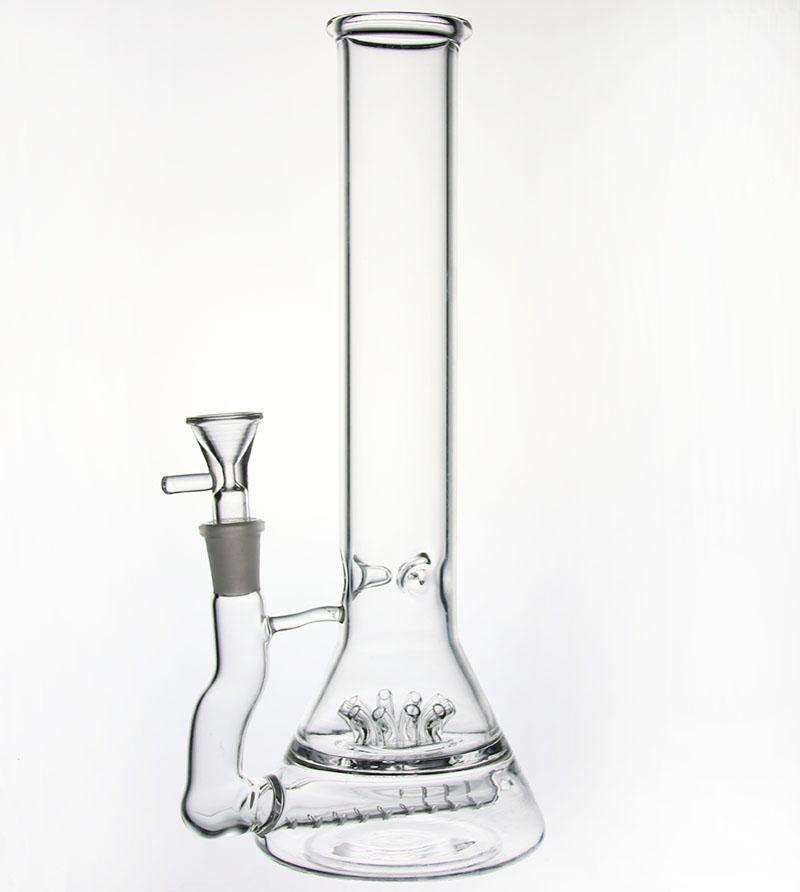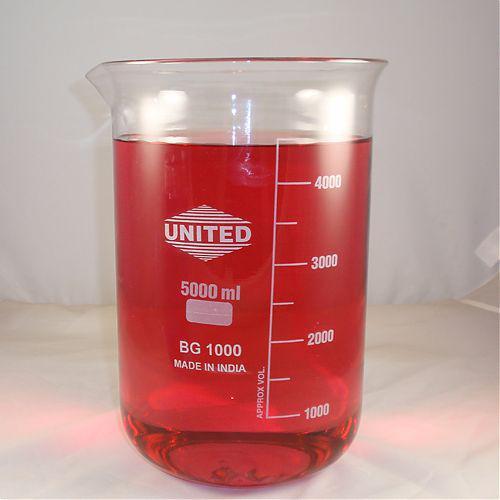The first image is the image on the left, the second image is the image on the right. For the images shown, is this caption "Each image contains colored liquid in a container, and at least one image includes a beaker without a handle containing red liquid." true? Answer yes or no. No. The first image is the image on the left, the second image is the image on the right. Given the left and right images, does the statement "In at least one image there is one clear beaker bong with glass mouth peice." hold true? Answer yes or no. Yes. 